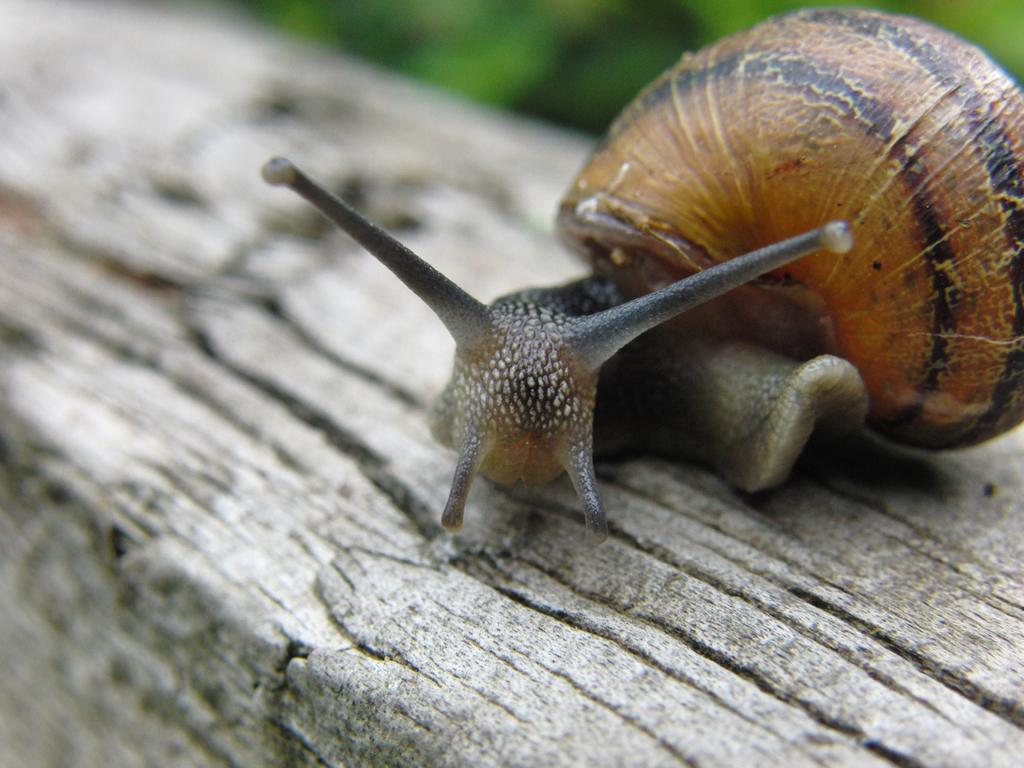What type of animal is in the image? There is a snail in the image. What surface is the snail on? The snail is on wood. Where is the snail located in the image? The snail is located in the center of the image. What type of company is depicted in the image? There is no company depicted in the image; it features a snail on wood. Is there a camp visible in the image? There is no camp present in the image; it features a snail on wood. 